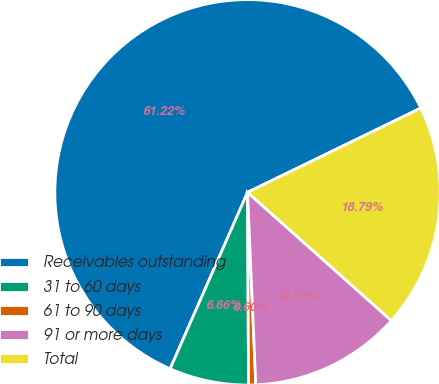Convert chart. <chart><loc_0><loc_0><loc_500><loc_500><pie_chart><fcel>Receivables outstanding<fcel>31 to 60 days<fcel>61 to 90 days<fcel>91 or more days<fcel>Total<nl><fcel>61.22%<fcel>6.66%<fcel>0.6%<fcel>12.73%<fcel>18.79%<nl></chart> 